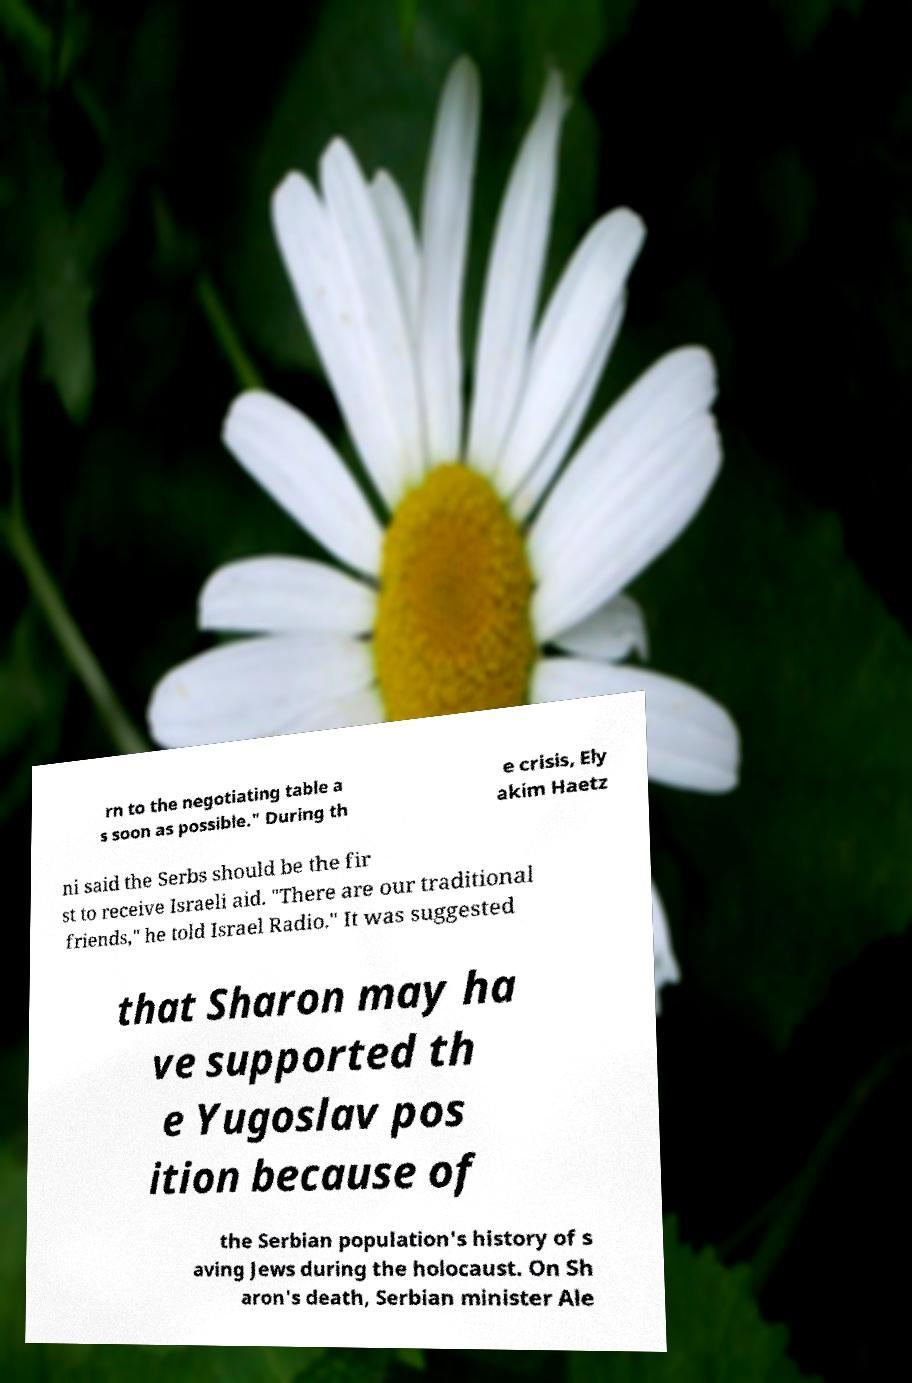Can you accurately transcribe the text from the provided image for me? rn to the negotiating table a s soon as possible." During th e crisis, Ely akim Haetz ni said the Serbs should be the fir st to receive Israeli aid. "There are our traditional friends," he told Israel Radio." It was suggested that Sharon may ha ve supported th e Yugoslav pos ition because of the Serbian population's history of s aving Jews during the holocaust. On Sh aron's death, Serbian minister Ale 